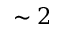Convert formula to latex. <formula><loc_0><loc_0><loc_500><loc_500>\sim 2</formula> 